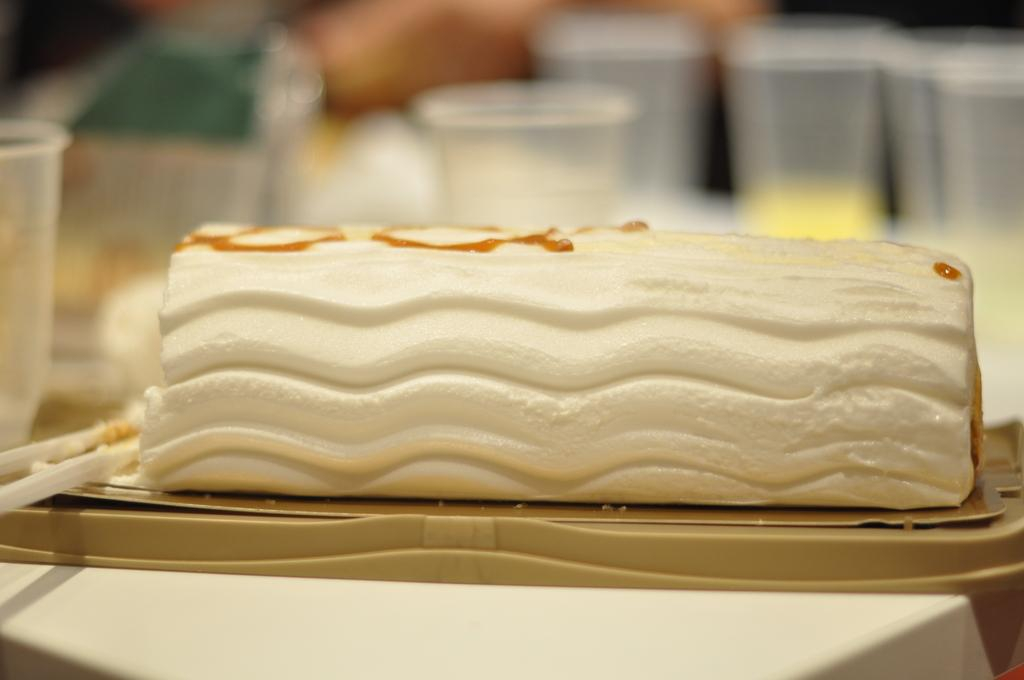What is the main subject in the foreground of the image? There is a food item on a plastic box in the foreground. What can be seen in the background of the image? There is a blurred image in the background. Are there any objects visible in the background? Yes, there are glasses in the background. How many chickens are present in the image? There are no chickens present in the image. What type of corn is being grown in the background of the image? There is no corn visible in the image. 